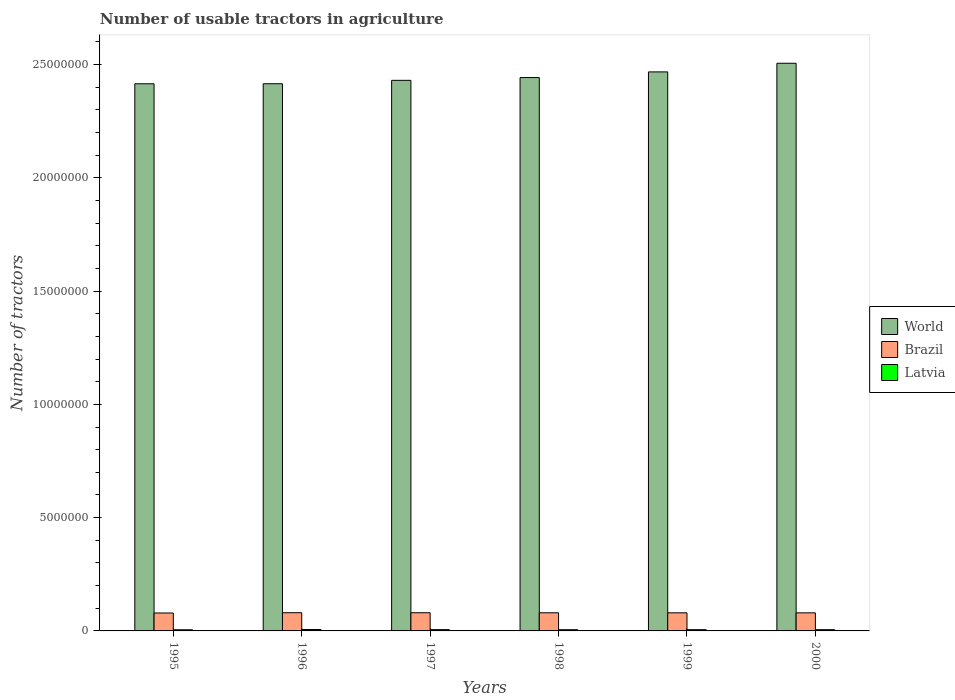How many groups of bars are there?
Give a very brief answer. 6. How many bars are there on the 4th tick from the left?
Your answer should be compact. 3. How many bars are there on the 1st tick from the right?
Ensure brevity in your answer.  3. In how many cases, is the number of bars for a given year not equal to the number of legend labels?
Your answer should be very brief. 0. What is the number of usable tractors in agriculture in Brazil in 1998?
Your response must be concise. 8.01e+05. Across all years, what is the maximum number of usable tractors in agriculture in Latvia?
Ensure brevity in your answer.  6.30e+04. Across all years, what is the minimum number of usable tractors in agriculture in Latvia?
Provide a succinct answer. 5.05e+04. In which year was the number of usable tractors in agriculture in World maximum?
Your answer should be compact. 2000. In which year was the number of usable tractors in agriculture in Latvia minimum?
Your answer should be very brief. 1995. What is the total number of usable tractors in agriculture in Brazil in the graph?
Offer a terse response. 4.79e+06. What is the difference between the number of usable tractors in agriculture in World in 1999 and that in 2000?
Provide a succinct answer. -3.82e+05. What is the difference between the number of usable tractors in agriculture in World in 2000 and the number of usable tractors in agriculture in Brazil in 1997?
Ensure brevity in your answer.  2.43e+07. What is the average number of usable tractors in agriculture in Latvia per year?
Your answer should be compact. 5.58e+04. In the year 1997, what is the difference between the number of usable tractors in agriculture in Latvia and number of usable tractors in agriculture in Brazil?
Ensure brevity in your answer.  -7.45e+05. In how many years, is the number of usable tractors in agriculture in Latvia greater than 8000000?
Provide a succinct answer. 0. What is the ratio of the number of usable tractors in agriculture in Latvia in 1999 to that in 2000?
Your response must be concise. 0.98. Is the number of usable tractors in agriculture in Brazil in 1995 less than that in 2000?
Your answer should be very brief. Yes. What is the difference between the highest and the second highest number of usable tractors in agriculture in Brazil?
Offer a very short reply. 1569. What is the difference between the highest and the lowest number of usable tractors in agriculture in Latvia?
Ensure brevity in your answer.  1.25e+04. In how many years, is the number of usable tractors in agriculture in Latvia greater than the average number of usable tractors in agriculture in Latvia taken over all years?
Offer a very short reply. 3. What does the 3rd bar from the left in 1999 represents?
Offer a terse response. Latvia. How many bars are there?
Offer a terse response. 18. Are all the bars in the graph horizontal?
Provide a short and direct response. No. How many years are there in the graph?
Your response must be concise. 6. Does the graph contain any zero values?
Your answer should be compact. No. Does the graph contain grids?
Give a very brief answer. No. How many legend labels are there?
Provide a short and direct response. 3. How are the legend labels stacked?
Your answer should be compact. Vertical. What is the title of the graph?
Offer a terse response. Number of usable tractors in agriculture. Does "Bahamas" appear as one of the legend labels in the graph?
Provide a short and direct response. No. What is the label or title of the X-axis?
Your answer should be compact. Years. What is the label or title of the Y-axis?
Give a very brief answer. Number of tractors. What is the Number of tractors in World in 1995?
Your answer should be compact. 2.41e+07. What is the Number of tractors of Brazil in 1995?
Make the answer very short. 7.91e+05. What is the Number of tractors of Latvia in 1995?
Offer a terse response. 5.05e+04. What is the Number of tractors in World in 1996?
Keep it short and to the point. 2.42e+07. What is the Number of tractors in Brazil in 1996?
Offer a terse response. 8.04e+05. What is the Number of tractors of Latvia in 1996?
Your answer should be compact. 6.30e+04. What is the Number of tractors in World in 1997?
Your answer should be very brief. 2.43e+07. What is the Number of tractors of Brazil in 1997?
Ensure brevity in your answer.  8.02e+05. What is the Number of tractors of Latvia in 1997?
Make the answer very short. 5.69e+04. What is the Number of tractors in World in 1998?
Make the answer very short. 2.44e+07. What is the Number of tractors in Brazil in 1998?
Your answer should be compact. 8.01e+05. What is the Number of tractors in Latvia in 1998?
Your response must be concise. 5.34e+04. What is the Number of tractors in World in 1999?
Ensure brevity in your answer.  2.47e+07. What is the Number of tractors in Brazil in 1999?
Ensure brevity in your answer.  7.99e+05. What is the Number of tractors of Latvia in 1999?
Keep it short and to the point. 5.49e+04. What is the Number of tractors in World in 2000?
Provide a short and direct response. 2.51e+07. What is the Number of tractors of Brazil in 2000?
Keep it short and to the point. 7.97e+05. What is the Number of tractors in Latvia in 2000?
Your response must be concise. 5.58e+04. Across all years, what is the maximum Number of tractors of World?
Your answer should be compact. 2.51e+07. Across all years, what is the maximum Number of tractors of Brazil?
Provide a succinct answer. 8.04e+05. Across all years, what is the maximum Number of tractors in Latvia?
Provide a succinct answer. 6.30e+04. Across all years, what is the minimum Number of tractors of World?
Give a very brief answer. 2.41e+07. Across all years, what is the minimum Number of tractors in Brazil?
Offer a very short reply. 7.91e+05. Across all years, what is the minimum Number of tractors of Latvia?
Give a very brief answer. 5.05e+04. What is the total Number of tractors in World in the graph?
Keep it short and to the point. 1.47e+08. What is the total Number of tractors of Brazil in the graph?
Provide a short and direct response. 4.79e+06. What is the total Number of tractors in Latvia in the graph?
Give a very brief answer. 3.35e+05. What is the difference between the Number of tractors of World in 1995 and that in 1996?
Provide a short and direct response. -1465. What is the difference between the Number of tractors in Brazil in 1995 and that in 1996?
Your answer should be compact. -1.25e+04. What is the difference between the Number of tractors in Latvia in 1995 and that in 1996?
Ensure brevity in your answer.  -1.25e+04. What is the difference between the Number of tractors in World in 1995 and that in 1997?
Make the answer very short. -1.52e+05. What is the difference between the Number of tractors of Brazil in 1995 and that in 1997?
Your answer should be compact. -1.09e+04. What is the difference between the Number of tractors of Latvia in 1995 and that in 1997?
Give a very brief answer. -6438. What is the difference between the Number of tractors of World in 1995 and that in 1998?
Your answer should be compact. -2.75e+05. What is the difference between the Number of tractors in Brazil in 1995 and that in 1998?
Provide a short and direct response. -9356. What is the difference between the Number of tractors in Latvia in 1995 and that in 1998?
Offer a very short reply. -2866. What is the difference between the Number of tractors in World in 1995 and that in 1999?
Offer a terse response. -5.24e+05. What is the difference between the Number of tractors of Brazil in 1995 and that in 1999?
Your answer should be very brief. -7787. What is the difference between the Number of tractors in Latvia in 1995 and that in 1999?
Your response must be concise. -4419. What is the difference between the Number of tractors of World in 1995 and that in 2000?
Provide a succinct answer. -9.05e+05. What is the difference between the Number of tractors of Brazil in 1995 and that in 2000?
Your response must be concise. -6218. What is the difference between the Number of tractors of Latvia in 1995 and that in 2000?
Give a very brief answer. -5315. What is the difference between the Number of tractors of World in 1996 and that in 1997?
Keep it short and to the point. -1.50e+05. What is the difference between the Number of tractors in Brazil in 1996 and that in 1997?
Give a very brief answer. 1569. What is the difference between the Number of tractors of Latvia in 1996 and that in 1997?
Your response must be concise. 6062. What is the difference between the Number of tractors of World in 1996 and that in 1998?
Give a very brief answer. -2.73e+05. What is the difference between the Number of tractors of Brazil in 1996 and that in 1998?
Make the answer very short. 3138. What is the difference between the Number of tractors in Latvia in 1996 and that in 1998?
Your answer should be compact. 9634. What is the difference between the Number of tractors of World in 1996 and that in 1999?
Provide a short and direct response. -5.22e+05. What is the difference between the Number of tractors in Brazil in 1996 and that in 1999?
Keep it short and to the point. 4707. What is the difference between the Number of tractors of Latvia in 1996 and that in 1999?
Ensure brevity in your answer.  8081. What is the difference between the Number of tractors in World in 1996 and that in 2000?
Offer a terse response. -9.04e+05. What is the difference between the Number of tractors of Brazil in 1996 and that in 2000?
Make the answer very short. 6276. What is the difference between the Number of tractors of Latvia in 1996 and that in 2000?
Your answer should be compact. 7185. What is the difference between the Number of tractors in World in 1997 and that in 1998?
Give a very brief answer. -1.23e+05. What is the difference between the Number of tractors of Brazil in 1997 and that in 1998?
Your answer should be compact. 1569. What is the difference between the Number of tractors in Latvia in 1997 and that in 1998?
Your answer should be very brief. 3572. What is the difference between the Number of tractors in World in 1997 and that in 1999?
Give a very brief answer. -3.72e+05. What is the difference between the Number of tractors in Brazil in 1997 and that in 1999?
Your answer should be compact. 3138. What is the difference between the Number of tractors of Latvia in 1997 and that in 1999?
Give a very brief answer. 2019. What is the difference between the Number of tractors of World in 1997 and that in 2000?
Offer a very short reply. -7.53e+05. What is the difference between the Number of tractors of Brazil in 1997 and that in 2000?
Provide a short and direct response. 4707. What is the difference between the Number of tractors of Latvia in 1997 and that in 2000?
Ensure brevity in your answer.  1123. What is the difference between the Number of tractors of World in 1998 and that in 1999?
Give a very brief answer. -2.49e+05. What is the difference between the Number of tractors of Brazil in 1998 and that in 1999?
Your answer should be compact. 1569. What is the difference between the Number of tractors in Latvia in 1998 and that in 1999?
Your answer should be compact. -1553. What is the difference between the Number of tractors of World in 1998 and that in 2000?
Ensure brevity in your answer.  -6.31e+05. What is the difference between the Number of tractors in Brazil in 1998 and that in 2000?
Offer a terse response. 3138. What is the difference between the Number of tractors of Latvia in 1998 and that in 2000?
Provide a succinct answer. -2449. What is the difference between the Number of tractors in World in 1999 and that in 2000?
Your answer should be compact. -3.82e+05. What is the difference between the Number of tractors of Brazil in 1999 and that in 2000?
Your response must be concise. 1569. What is the difference between the Number of tractors in Latvia in 1999 and that in 2000?
Offer a terse response. -896. What is the difference between the Number of tractors of World in 1995 and the Number of tractors of Brazil in 1996?
Ensure brevity in your answer.  2.33e+07. What is the difference between the Number of tractors in World in 1995 and the Number of tractors in Latvia in 1996?
Make the answer very short. 2.41e+07. What is the difference between the Number of tractors of Brazil in 1995 and the Number of tractors of Latvia in 1996?
Provide a succinct answer. 7.28e+05. What is the difference between the Number of tractors of World in 1995 and the Number of tractors of Brazil in 1997?
Provide a succinct answer. 2.33e+07. What is the difference between the Number of tractors of World in 1995 and the Number of tractors of Latvia in 1997?
Offer a very short reply. 2.41e+07. What is the difference between the Number of tractors in Brazil in 1995 and the Number of tractors in Latvia in 1997?
Ensure brevity in your answer.  7.34e+05. What is the difference between the Number of tractors of World in 1995 and the Number of tractors of Brazil in 1998?
Provide a succinct answer. 2.33e+07. What is the difference between the Number of tractors of World in 1995 and the Number of tractors of Latvia in 1998?
Your answer should be very brief. 2.41e+07. What is the difference between the Number of tractors in Brazil in 1995 and the Number of tractors in Latvia in 1998?
Your response must be concise. 7.38e+05. What is the difference between the Number of tractors in World in 1995 and the Number of tractors in Brazil in 1999?
Provide a succinct answer. 2.33e+07. What is the difference between the Number of tractors of World in 1995 and the Number of tractors of Latvia in 1999?
Your answer should be very brief. 2.41e+07. What is the difference between the Number of tractors of Brazil in 1995 and the Number of tractors of Latvia in 1999?
Provide a short and direct response. 7.36e+05. What is the difference between the Number of tractors in World in 1995 and the Number of tractors in Brazil in 2000?
Offer a terse response. 2.34e+07. What is the difference between the Number of tractors of World in 1995 and the Number of tractors of Latvia in 2000?
Give a very brief answer. 2.41e+07. What is the difference between the Number of tractors in Brazil in 1995 and the Number of tractors in Latvia in 2000?
Offer a very short reply. 7.35e+05. What is the difference between the Number of tractors in World in 1996 and the Number of tractors in Brazil in 1997?
Give a very brief answer. 2.33e+07. What is the difference between the Number of tractors of World in 1996 and the Number of tractors of Latvia in 1997?
Give a very brief answer. 2.41e+07. What is the difference between the Number of tractors of Brazil in 1996 and the Number of tractors of Latvia in 1997?
Ensure brevity in your answer.  7.47e+05. What is the difference between the Number of tractors in World in 1996 and the Number of tractors in Brazil in 1998?
Keep it short and to the point. 2.33e+07. What is the difference between the Number of tractors in World in 1996 and the Number of tractors in Latvia in 1998?
Offer a terse response. 2.41e+07. What is the difference between the Number of tractors in Brazil in 1996 and the Number of tractors in Latvia in 1998?
Make the answer very short. 7.50e+05. What is the difference between the Number of tractors in World in 1996 and the Number of tractors in Brazil in 1999?
Provide a short and direct response. 2.34e+07. What is the difference between the Number of tractors in World in 1996 and the Number of tractors in Latvia in 1999?
Your answer should be compact. 2.41e+07. What is the difference between the Number of tractors in Brazil in 1996 and the Number of tractors in Latvia in 1999?
Ensure brevity in your answer.  7.49e+05. What is the difference between the Number of tractors of World in 1996 and the Number of tractors of Brazil in 2000?
Offer a terse response. 2.34e+07. What is the difference between the Number of tractors of World in 1996 and the Number of tractors of Latvia in 2000?
Offer a terse response. 2.41e+07. What is the difference between the Number of tractors in Brazil in 1996 and the Number of tractors in Latvia in 2000?
Keep it short and to the point. 7.48e+05. What is the difference between the Number of tractors in World in 1997 and the Number of tractors in Brazil in 1998?
Provide a succinct answer. 2.35e+07. What is the difference between the Number of tractors in World in 1997 and the Number of tractors in Latvia in 1998?
Provide a short and direct response. 2.42e+07. What is the difference between the Number of tractors in Brazil in 1997 and the Number of tractors in Latvia in 1998?
Your answer should be very brief. 7.49e+05. What is the difference between the Number of tractors in World in 1997 and the Number of tractors in Brazil in 1999?
Provide a short and direct response. 2.35e+07. What is the difference between the Number of tractors in World in 1997 and the Number of tractors in Latvia in 1999?
Ensure brevity in your answer.  2.42e+07. What is the difference between the Number of tractors of Brazil in 1997 and the Number of tractors of Latvia in 1999?
Keep it short and to the point. 7.47e+05. What is the difference between the Number of tractors in World in 1997 and the Number of tractors in Brazil in 2000?
Give a very brief answer. 2.35e+07. What is the difference between the Number of tractors of World in 1997 and the Number of tractors of Latvia in 2000?
Make the answer very short. 2.42e+07. What is the difference between the Number of tractors of Brazil in 1997 and the Number of tractors of Latvia in 2000?
Give a very brief answer. 7.46e+05. What is the difference between the Number of tractors of World in 1998 and the Number of tractors of Brazil in 1999?
Your answer should be compact. 2.36e+07. What is the difference between the Number of tractors of World in 1998 and the Number of tractors of Latvia in 1999?
Your answer should be compact. 2.44e+07. What is the difference between the Number of tractors in Brazil in 1998 and the Number of tractors in Latvia in 1999?
Keep it short and to the point. 7.46e+05. What is the difference between the Number of tractors in World in 1998 and the Number of tractors in Brazil in 2000?
Your answer should be very brief. 2.36e+07. What is the difference between the Number of tractors of World in 1998 and the Number of tractors of Latvia in 2000?
Offer a terse response. 2.44e+07. What is the difference between the Number of tractors of Brazil in 1998 and the Number of tractors of Latvia in 2000?
Provide a short and direct response. 7.45e+05. What is the difference between the Number of tractors in World in 1999 and the Number of tractors in Brazil in 2000?
Your answer should be compact. 2.39e+07. What is the difference between the Number of tractors of World in 1999 and the Number of tractors of Latvia in 2000?
Offer a very short reply. 2.46e+07. What is the difference between the Number of tractors of Brazil in 1999 and the Number of tractors of Latvia in 2000?
Ensure brevity in your answer.  7.43e+05. What is the average Number of tractors of World per year?
Keep it short and to the point. 2.45e+07. What is the average Number of tractors of Brazil per year?
Offer a terse response. 7.99e+05. What is the average Number of tractors in Latvia per year?
Ensure brevity in your answer.  5.58e+04. In the year 1995, what is the difference between the Number of tractors in World and Number of tractors in Brazil?
Make the answer very short. 2.34e+07. In the year 1995, what is the difference between the Number of tractors in World and Number of tractors in Latvia?
Your response must be concise. 2.41e+07. In the year 1995, what is the difference between the Number of tractors of Brazil and Number of tractors of Latvia?
Offer a very short reply. 7.41e+05. In the year 1996, what is the difference between the Number of tractors of World and Number of tractors of Brazil?
Provide a succinct answer. 2.33e+07. In the year 1996, what is the difference between the Number of tractors of World and Number of tractors of Latvia?
Provide a succinct answer. 2.41e+07. In the year 1996, what is the difference between the Number of tractors of Brazil and Number of tractors of Latvia?
Ensure brevity in your answer.  7.41e+05. In the year 1997, what is the difference between the Number of tractors in World and Number of tractors in Brazil?
Offer a terse response. 2.35e+07. In the year 1997, what is the difference between the Number of tractors of World and Number of tractors of Latvia?
Offer a very short reply. 2.42e+07. In the year 1997, what is the difference between the Number of tractors of Brazil and Number of tractors of Latvia?
Ensure brevity in your answer.  7.45e+05. In the year 1998, what is the difference between the Number of tractors of World and Number of tractors of Brazil?
Provide a short and direct response. 2.36e+07. In the year 1998, what is the difference between the Number of tractors of World and Number of tractors of Latvia?
Ensure brevity in your answer.  2.44e+07. In the year 1998, what is the difference between the Number of tractors in Brazil and Number of tractors in Latvia?
Make the answer very short. 7.47e+05. In the year 1999, what is the difference between the Number of tractors in World and Number of tractors in Brazil?
Offer a terse response. 2.39e+07. In the year 1999, what is the difference between the Number of tractors of World and Number of tractors of Latvia?
Your response must be concise. 2.46e+07. In the year 1999, what is the difference between the Number of tractors in Brazil and Number of tractors in Latvia?
Your answer should be very brief. 7.44e+05. In the year 2000, what is the difference between the Number of tractors in World and Number of tractors in Brazil?
Offer a terse response. 2.43e+07. In the year 2000, what is the difference between the Number of tractors of World and Number of tractors of Latvia?
Your response must be concise. 2.50e+07. In the year 2000, what is the difference between the Number of tractors in Brazil and Number of tractors in Latvia?
Provide a succinct answer. 7.42e+05. What is the ratio of the Number of tractors of World in 1995 to that in 1996?
Provide a short and direct response. 1. What is the ratio of the Number of tractors of Brazil in 1995 to that in 1996?
Give a very brief answer. 0.98. What is the ratio of the Number of tractors of Latvia in 1995 to that in 1996?
Offer a terse response. 0.8. What is the ratio of the Number of tractors of World in 1995 to that in 1997?
Provide a succinct answer. 0.99. What is the ratio of the Number of tractors in Brazil in 1995 to that in 1997?
Offer a terse response. 0.99. What is the ratio of the Number of tractors of Latvia in 1995 to that in 1997?
Provide a short and direct response. 0.89. What is the ratio of the Number of tractors of World in 1995 to that in 1998?
Your response must be concise. 0.99. What is the ratio of the Number of tractors of Brazil in 1995 to that in 1998?
Your answer should be very brief. 0.99. What is the ratio of the Number of tractors of Latvia in 1995 to that in 1998?
Keep it short and to the point. 0.95. What is the ratio of the Number of tractors in World in 1995 to that in 1999?
Provide a short and direct response. 0.98. What is the ratio of the Number of tractors in Brazil in 1995 to that in 1999?
Offer a very short reply. 0.99. What is the ratio of the Number of tractors in Latvia in 1995 to that in 1999?
Your response must be concise. 0.92. What is the ratio of the Number of tractors in World in 1995 to that in 2000?
Offer a very short reply. 0.96. What is the ratio of the Number of tractors of Latvia in 1995 to that in 2000?
Your answer should be very brief. 0.9. What is the ratio of the Number of tractors of World in 1996 to that in 1997?
Provide a short and direct response. 0.99. What is the ratio of the Number of tractors in Brazil in 1996 to that in 1997?
Offer a terse response. 1. What is the ratio of the Number of tractors in Latvia in 1996 to that in 1997?
Offer a very short reply. 1.11. What is the ratio of the Number of tractors in Latvia in 1996 to that in 1998?
Your answer should be very brief. 1.18. What is the ratio of the Number of tractors of World in 1996 to that in 1999?
Your answer should be very brief. 0.98. What is the ratio of the Number of tractors in Brazil in 1996 to that in 1999?
Ensure brevity in your answer.  1.01. What is the ratio of the Number of tractors of Latvia in 1996 to that in 1999?
Offer a very short reply. 1.15. What is the ratio of the Number of tractors in World in 1996 to that in 2000?
Offer a terse response. 0.96. What is the ratio of the Number of tractors in Brazil in 1996 to that in 2000?
Provide a short and direct response. 1.01. What is the ratio of the Number of tractors of Latvia in 1996 to that in 2000?
Your answer should be compact. 1.13. What is the ratio of the Number of tractors in Brazil in 1997 to that in 1998?
Provide a succinct answer. 1. What is the ratio of the Number of tractors of Latvia in 1997 to that in 1998?
Give a very brief answer. 1.07. What is the ratio of the Number of tractors in World in 1997 to that in 1999?
Provide a short and direct response. 0.98. What is the ratio of the Number of tractors of Latvia in 1997 to that in 1999?
Make the answer very short. 1.04. What is the ratio of the Number of tractors in World in 1997 to that in 2000?
Offer a very short reply. 0.97. What is the ratio of the Number of tractors in Brazil in 1997 to that in 2000?
Keep it short and to the point. 1.01. What is the ratio of the Number of tractors of Latvia in 1997 to that in 2000?
Offer a terse response. 1.02. What is the ratio of the Number of tractors of Brazil in 1998 to that in 1999?
Provide a succinct answer. 1. What is the ratio of the Number of tractors of Latvia in 1998 to that in 1999?
Give a very brief answer. 0.97. What is the ratio of the Number of tractors in World in 1998 to that in 2000?
Provide a short and direct response. 0.97. What is the ratio of the Number of tractors of Brazil in 1998 to that in 2000?
Your answer should be very brief. 1. What is the ratio of the Number of tractors in Latvia in 1998 to that in 2000?
Your response must be concise. 0.96. What is the ratio of the Number of tractors in Brazil in 1999 to that in 2000?
Give a very brief answer. 1. What is the ratio of the Number of tractors in Latvia in 1999 to that in 2000?
Give a very brief answer. 0.98. What is the difference between the highest and the second highest Number of tractors in World?
Offer a terse response. 3.82e+05. What is the difference between the highest and the second highest Number of tractors in Brazil?
Provide a short and direct response. 1569. What is the difference between the highest and the second highest Number of tractors of Latvia?
Ensure brevity in your answer.  6062. What is the difference between the highest and the lowest Number of tractors of World?
Ensure brevity in your answer.  9.05e+05. What is the difference between the highest and the lowest Number of tractors in Brazil?
Your response must be concise. 1.25e+04. What is the difference between the highest and the lowest Number of tractors of Latvia?
Ensure brevity in your answer.  1.25e+04. 